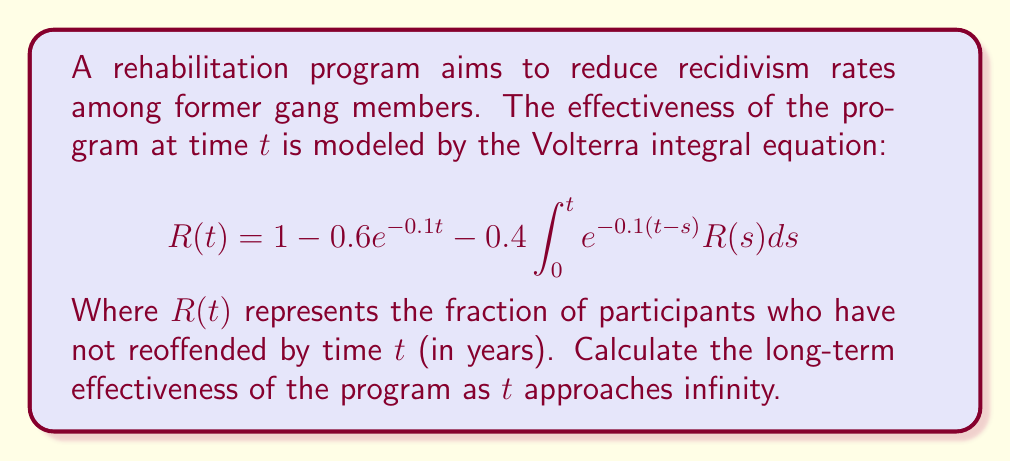Could you help me with this problem? To solve this problem, we'll follow these steps:

1) First, we need to recognize that as $t$ approaches infinity, $R(t)$ should approach a constant value. Let's call this limit $R_{\infty}$.

2) As $t \to \infty$, $e^{-0.1t} \to 0$. So, the equation becomes:

   $$R_{\infty} = 1 - 0.4\int_0^{\infty} e^{-0.1(t-s)}R(s)ds$$

3) Now, we can use the property of convolution integrals. As $t \to \infty$, $R(s)$ in the integral approaches $R_{\infty}$. So:

   $$R_{\infty} = 1 - 0.4R_{\infty}\int_0^{\infty} e^{-0.1u}du$$

   where $u = t-s$

4) Solve the integral:

   $$\int_0^{\infty} e^{-0.1u}du = [-10e^{-0.1u}]_0^{\infty} = 10$$

5) Substitute this back into the equation:

   $$R_{\infty} = 1 - 4R_{\infty}$$

6) Solve for $R_{\infty}$:

   $$5R_{\infty} = 1$$
   $$R_{\infty} = \frac{1}{5} = 0.2$$

Therefore, in the long term, 20% of the participants are expected to not reoffend.
Answer: $0.2$ or $20\%$ 